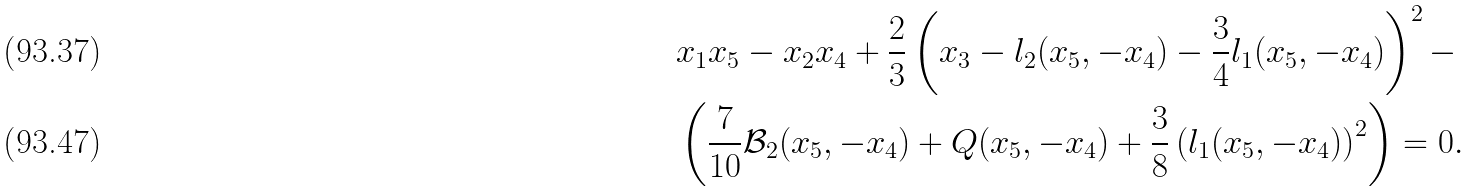<formula> <loc_0><loc_0><loc_500><loc_500>& x _ { 1 } x _ { 5 } - x _ { 2 } x _ { 4 } + \frac { 2 } { 3 } \left ( x _ { 3 } - l _ { 2 } ( x _ { 5 } , - x _ { 4 } ) - \frac { 3 } { 4 } l _ { 1 } ( x _ { 5 } , - x _ { 4 } ) \right ) ^ { 2 } - \\ & \left ( \frac { 7 } { 1 0 } \mathcal { B } _ { 2 } ( x _ { 5 } , - x _ { 4 } ) + Q ( x _ { 5 } , - x _ { 4 } ) + \frac { 3 } { 8 } \left ( l _ { 1 } ( x _ { 5 } , - x _ { 4 } ) \right ) ^ { 2 } \right ) = 0 .</formula> 